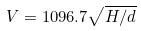Convert formula to latex. <formula><loc_0><loc_0><loc_500><loc_500>V = 1 0 9 6 . 7 \sqrt { H / d }</formula> 